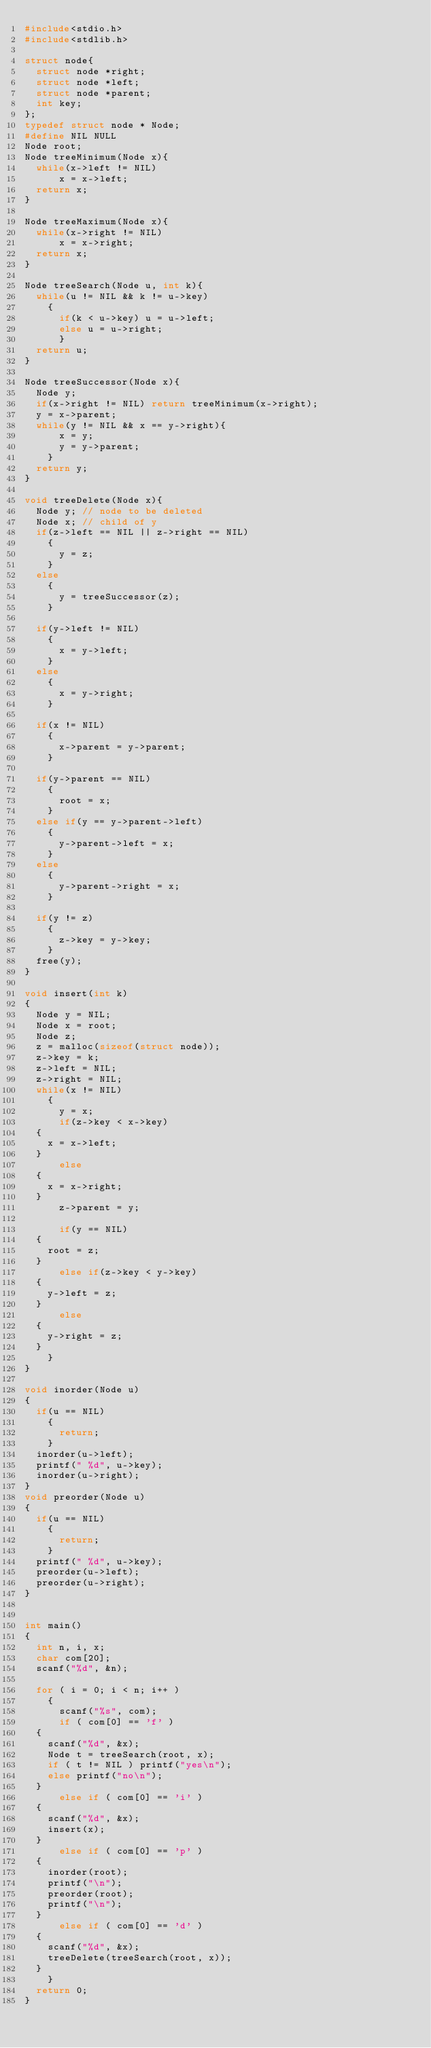<code> <loc_0><loc_0><loc_500><loc_500><_C_>#include<stdio.h>
#include<stdlib.h>

struct node{
  struct node *right;
  struct node *left;
  struct node *parent;
  int key;
};
typedef struct node * Node;
#define NIL NULL
Node root;
Node treeMinimum(Node x){
  while(x->left != NIL)   
      x = x->left;
  return x;
}

Node treeMaximum(Node x){
  while(x->right != NIL)
      x = x->right;
  return x;
}

Node treeSearch(Node u, int k){
  while(u != NIL && k != u->key)
    {
      if(k < u->key) u = u->left;
      else u = u->right;
      }
  return u;
}

Node treeSuccessor(Node x){
  Node y;
  if(x->right != NIL) return treeMinimum(x->right);
  y = x->parent;
  while(y != NIL && x == y->right){
      x = y;
      y = y->parent;
    }
  return y;
}

void treeDelete(Node x){
  Node y; // node to be deleted
  Node x; // child of y
  if(z->left == NIL || z->right == NIL)
    {
      y = z;
    }
  else
    {
      y = treeSuccessor(z);
    }
  
  if(y->left != NIL)
    {
      x = y->left;
    }
  else
    {
      x = y->right;
    }
  
  if(x != NIL)
    {
      x->parent = y->parent;
    }
  
  if(y->parent == NIL)
    {
      root = x;
    }
  else if(y == y->parent->left)
    {
      y->parent->left = x;
    }
  else
    {
      y->parent->right = x;
    }
  
  if(y != z)
    {
      z->key = y->key;
    }
  free(y);
}

void insert(int k)
{
  Node y = NIL;
  Node x = root;
  Node z;
  z = malloc(sizeof(struct node));
  z->key = k;
  z->left = NIL;
  z->right = NIL;
  while(x != NIL)
    {
      y = x;
      if(z->key < x->key)
	{
	  x = x->left;
	}
      else
	{
	  x = x->right;
	}
      z->parent = y;

      if(y == NIL)
	{
	  root = z;
	}
      else if(z->key < y->key)
	{
	  y->left = z;
	}
      else
	{
	  y->right = z;
	}
    }
}

void inorder(Node u)
{
  if(u == NIL)
    {
      return;
    }
  inorder(u->left);
  printf(" %d", u->key);
  inorder(u->right);
}
void preorder(Node u)
{
  if(u == NIL)
    {
      return;
    }
  printf(" %d", u->key);
  preorder(u->left);
  preorder(u->right);
}


int main()
{
  int n, i, x;
  char com[20];
  scanf("%d", &n);

  for ( i = 0; i < n; i++ )
    {
      scanf("%s", com);
      if ( com[0] == 'f' )
	{
	  scanf("%d", &x);
	  Node t = treeSearch(root, x);
	  if ( t != NIL ) printf("yes\n");
	  else printf("no\n");
	}
      else if ( com[0] == 'i' )
	{
	  scanf("%d", &x);
	  insert(x);
	}
      else if ( com[0] == 'p' )
	{
	  inorder(root);
	  printf("\n");
	  preorder(root);
	  printf("\n");
	}
      else if ( com[0] == 'd' )
	{
	  scanf("%d", &x);
	  treeDelete(treeSearch(root, x));
	}
    }
  return 0;
}

</code> 